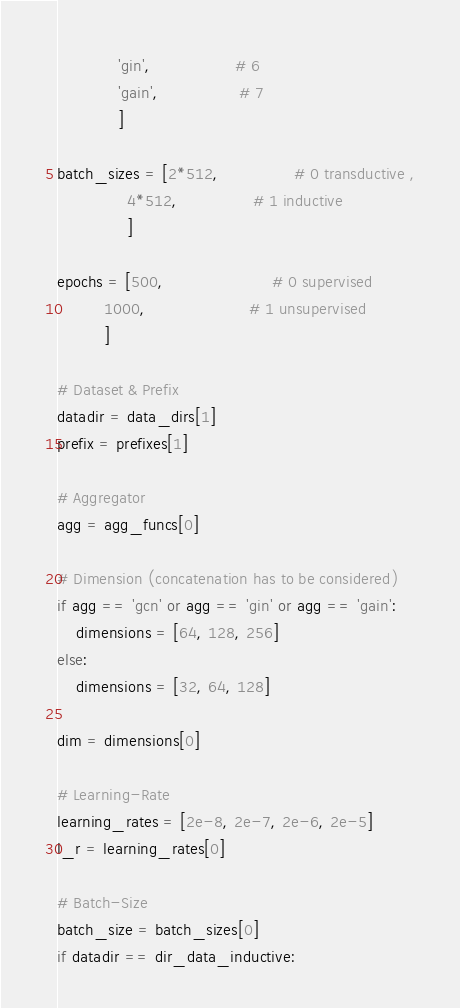Convert code to text. <code><loc_0><loc_0><loc_500><loc_500><_Python_>             'gin',                  # 6
             'gain',                 # 7
             ]

batch_sizes = [2*512,                # 0 transductive ,
               4*512,                # 1 inductive
               ]

epochs = [500,                       # 0 supervised
          1000,                      # 1 unsupervised
          ]

# Dataset & Prefix
datadir = data_dirs[1]
prefix = prefixes[1]

# Aggregator
agg = agg_funcs[0]

# Dimension (concatenation has to be considered)
if agg == 'gcn' or agg == 'gin' or agg == 'gain':
    dimensions = [64, 128, 256]
else:
    dimensions = [32, 64, 128]

dim = dimensions[0]

# Learning-Rate
learning_rates = [2e-8, 2e-7, 2e-6, 2e-5]
l_r = learning_rates[0]

# Batch-Size
batch_size = batch_sizes[0]
if datadir == dir_data_inductive:</code> 